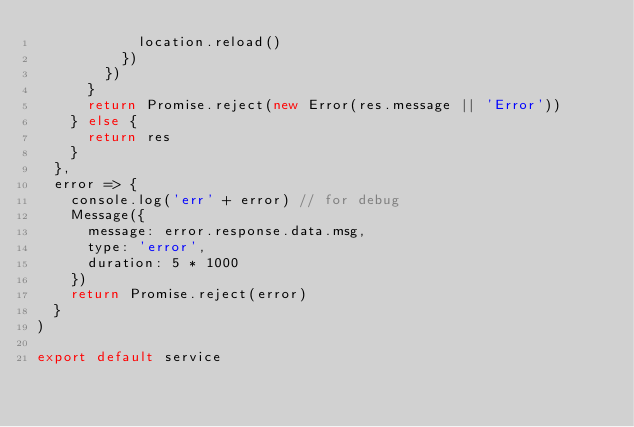Convert code to text. <code><loc_0><loc_0><loc_500><loc_500><_JavaScript_>            location.reload()
          })
        })
      }
      return Promise.reject(new Error(res.message || 'Error'))
    } else {
      return res
    }
  },
  error => {
    console.log('err' + error) // for debug
    Message({
      message: error.response.data.msg,
      type: 'error',
      duration: 5 * 1000
    })
    return Promise.reject(error)
  }
)

export default service
</code> 